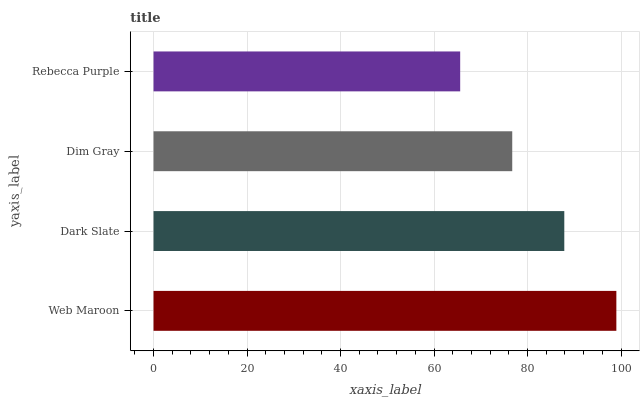Is Rebecca Purple the minimum?
Answer yes or no. Yes. Is Web Maroon the maximum?
Answer yes or no. Yes. Is Dark Slate the minimum?
Answer yes or no. No. Is Dark Slate the maximum?
Answer yes or no. No. Is Web Maroon greater than Dark Slate?
Answer yes or no. Yes. Is Dark Slate less than Web Maroon?
Answer yes or no. Yes. Is Dark Slate greater than Web Maroon?
Answer yes or no. No. Is Web Maroon less than Dark Slate?
Answer yes or no. No. Is Dark Slate the high median?
Answer yes or no. Yes. Is Dim Gray the low median?
Answer yes or no. Yes. Is Dim Gray the high median?
Answer yes or no. No. Is Dark Slate the low median?
Answer yes or no. No. 